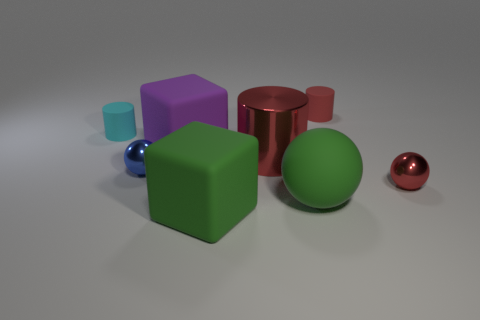The other matte object that is the same shape as the small blue thing is what color?
Provide a succinct answer. Green. Do the green matte thing that is behind the green matte cube and the red metal cylinder that is behind the blue ball have the same size?
Offer a very short reply. Yes. What color is the big matte cube that is in front of the small metal thing that is right of the matte cylinder right of the cyan matte cylinder?
Ensure brevity in your answer.  Green. Is there a large green object of the same shape as the purple object?
Provide a short and direct response. Yes. Are there the same number of large objects that are left of the large red cylinder and green balls that are on the right side of the tiny blue sphere?
Keep it short and to the point. No. Do the green matte thing that is in front of the large matte ball and the small red shiny object have the same shape?
Provide a succinct answer. No. Do the big red thing and the purple object have the same shape?
Offer a terse response. No. What number of matte objects are large green cubes or cylinders?
Your response must be concise. 3. There is a large block that is the same color as the big sphere; what material is it?
Make the answer very short. Rubber. Do the green matte ball and the red shiny ball have the same size?
Ensure brevity in your answer.  No. 